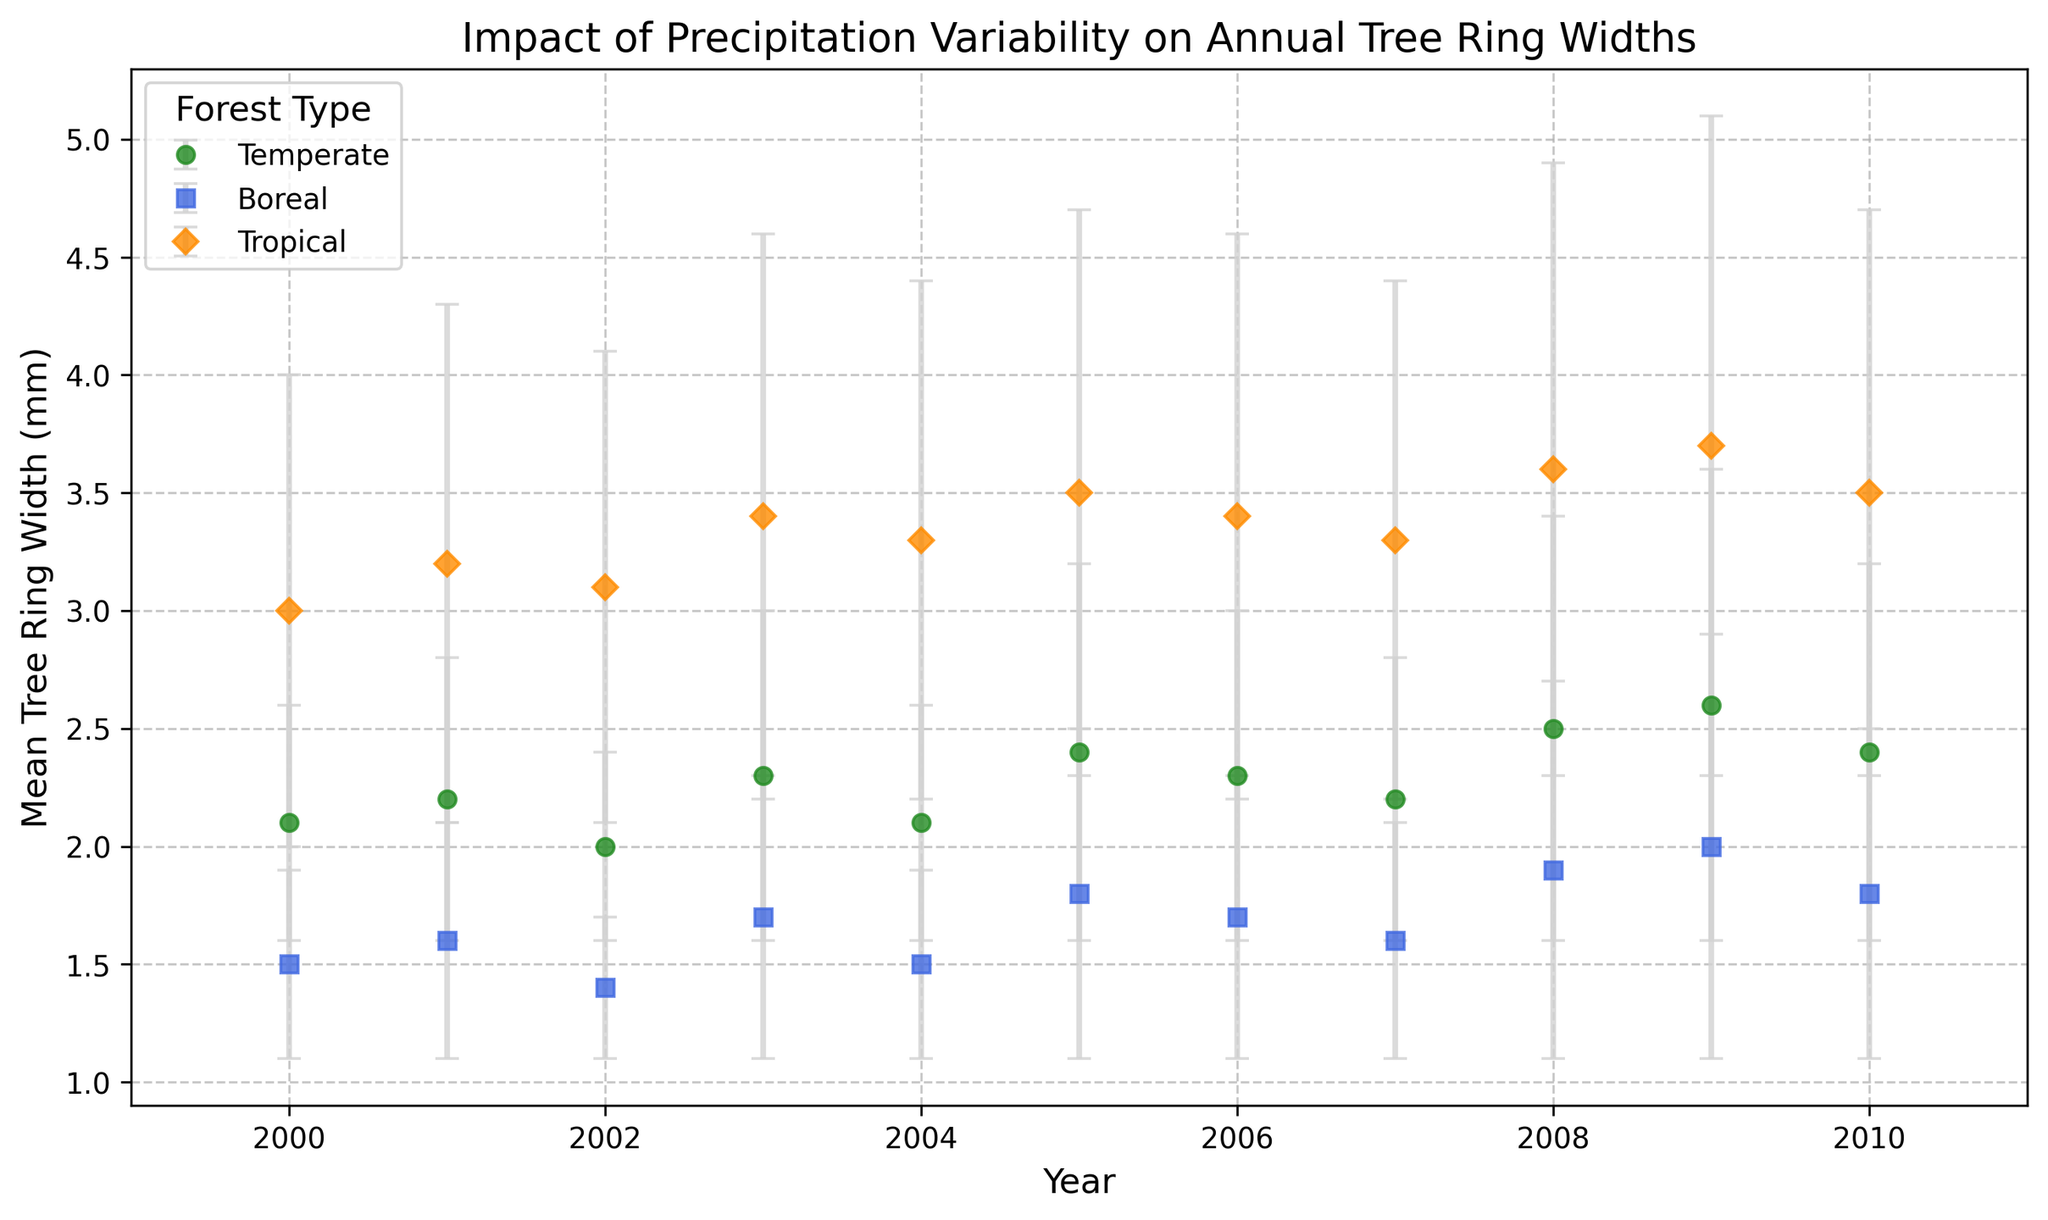How does the tree ring width in boreal forests compare to tropical forests in the year 2003? To answer this, look at the data points for both Boreal and Tropical forests in the year 2003. Boreal forests have a mean tree ring width of 1.7 mm, while Tropical forests have a mean tree ring width of 3.4 mm. The Tropical forests have a larger tree ring width.
Answer: Tropical forests have a larger tree ring width Which forest type shows the maximum mean tree ring width across the years? Examine the highest mean tree ring width data points for each forest type. Tropical forests in the year 2009 exhibit the maximum mean tree ring width of 3.7 mm.
Answer: Tropical forests What is the average mean tree ring width for temperate forests between the years 2000 and 2010? To find this, sum up the mean tree ring widths for Temperate forests from 2000 to 2010 and divide by the number of years. Mean widths = 2.1 + 2.2 + 2.0 + 2.3 + 2.1 + 2.4 + 2.3 + 2.2 + 2.5 + 2.6 + 2.4 = 24.1 mm. Average = 24.1 / 11 ≈ 2.19 mm.
Answer: 2.19 mm How do the error bars of temperate forests in 2005 compare to tropical forests in 2005? Look at the length of the error bars for both forest types. Temperate forests in 2005 have an error bar length of 0.8 mm, while Tropical forests have an error bar length of 1.2 mm. Tropical forests have longer error bars.
Answer: Tropical forests have longer error bars In which year do boreal forests show the highest variability in tree ring width? The variability is represented by the error bars. Look for the longest error bar in the Boreal forests. In 2008, Boreal forests have an error bar of 0.8 mm, which is the highest across the years.
Answer: 2008 Which forest type had the smallest mean tree ring width in the year 2002? Compare the mean tree ring widths of all forest types in 2002. Boreal forests have the smallest mean tree ring width of 1.4 mm.
Answer: Boreal forests What’s the trend of mean tree ring width in temperate forests from 2000 to 2010? Observe the trend line of the mean tree ring widths. From 2000 to 2010, the mean tree ring width in Temperate forests shows an overall increasing trend despite some fluctuations.
Answer: Increasing trend By how much does the mean tree ring width of temperate forests change from 2008 to 2009? Subtract the mean tree ring width in 2008 from that in 2009. For Temperate forests, the mean width changes from 2.5 mm in 2008 to 2.6 mm in 2009, a change of 0.1 mm.
Answer: 0.1 mm Which forest type has more consistent tree ring widths over the years, as indicated by the error bars? Consistency is indicated by smaller error bars. Look at the error bars of each forest type over the years. Temperate forests have relatively smaller error bars compared to Boreal and Tropical forests.
Answer: Temperate forests 